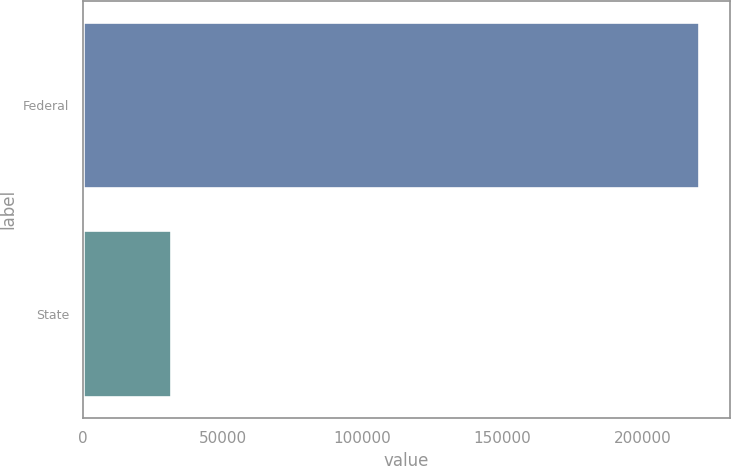Convert chart. <chart><loc_0><loc_0><loc_500><loc_500><bar_chart><fcel>Federal<fcel>State<nl><fcel>220124<fcel>31685<nl></chart> 